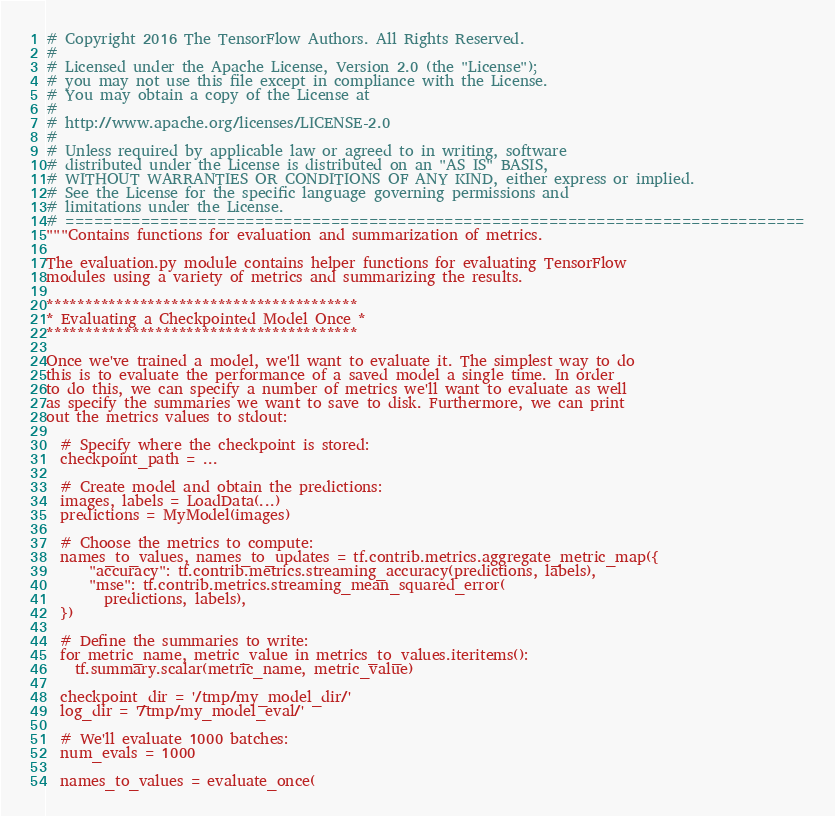Convert code to text. <code><loc_0><loc_0><loc_500><loc_500><_Python_># Copyright 2016 The TensorFlow Authors. All Rights Reserved.
#
# Licensed under the Apache License, Version 2.0 (the "License");
# you may not use this file except in compliance with the License.
# You may obtain a copy of the License at
#
# http://www.apache.org/licenses/LICENSE-2.0
#
# Unless required by applicable law or agreed to in writing, software
# distributed under the License is distributed on an "AS IS" BASIS,
# WITHOUT WARRANTIES OR CONDITIONS OF ANY KIND, either express or implied.
# See the License for the specific language governing permissions and
# limitations under the License.
# ==============================================================================
"""Contains functions for evaluation and summarization of metrics.

The evaluation.py module contains helper functions for evaluating TensorFlow
modules using a variety of metrics and summarizing the results.

****************************************
* Evaluating a Checkpointed Model Once *
****************************************

Once we've trained a model, we'll want to evaluate it. The simplest way to do
this is to evaluate the performance of a saved model a single time. In order
to do this, we can specify a number of metrics we'll want to evaluate as well
as specify the summaries we want to save to disk. Furthermore, we can print
out the metrics values to stdout:

  # Specify where the checkpoint is stored:
  checkpoint_path = ...

  # Create model and obtain the predictions:
  images, labels = LoadData(...)
  predictions = MyModel(images)

  # Choose the metrics to compute:
  names_to_values, names_to_updates = tf.contrib.metrics.aggregate_metric_map({
      "accuracy": tf.contrib.metrics.streaming_accuracy(predictions, labels),
      "mse": tf.contrib.metrics.streaming_mean_squared_error(
        predictions, labels),
  })

  # Define the summaries to write:
  for metric_name, metric_value in metrics_to_values.iteritems():
    tf.summary.scalar(metric_name, metric_value)

  checkpoint_dir = '/tmp/my_model_dir/'
  log_dir = '/tmp/my_model_eval/'

  # We'll evaluate 1000 batches:
  num_evals = 1000

  names_to_values = evaluate_once(</code> 